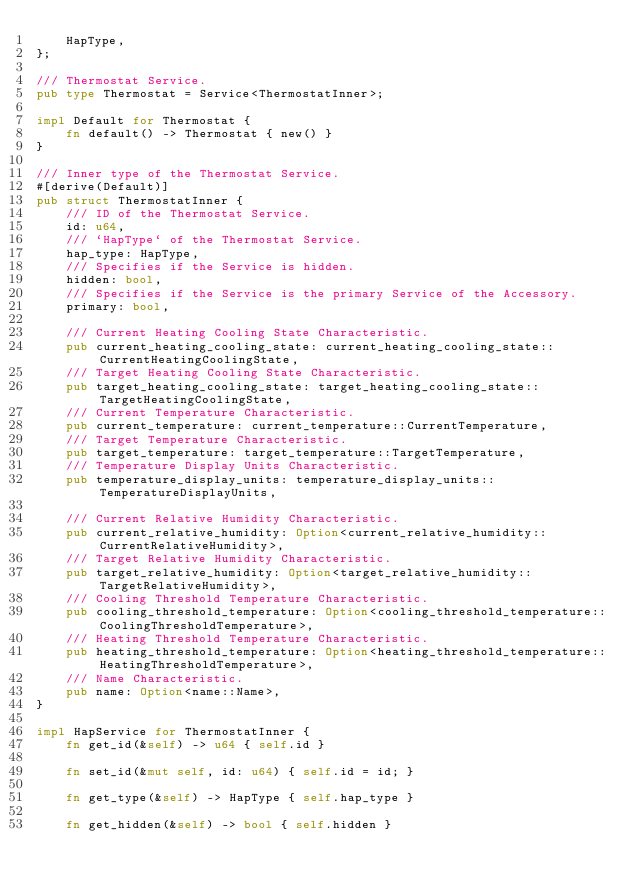Convert code to text. <code><loc_0><loc_0><loc_500><loc_500><_Rust_>    HapType,
};

/// Thermostat Service.
pub type Thermostat = Service<ThermostatInner>;

impl Default for Thermostat {
    fn default() -> Thermostat { new() }
}

/// Inner type of the Thermostat Service.
#[derive(Default)]
pub struct ThermostatInner {
    /// ID of the Thermostat Service.
    id: u64,
    /// `HapType` of the Thermostat Service.
    hap_type: HapType,
    /// Specifies if the Service is hidden.
    hidden: bool,
    /// Specifies if the Service is the primary Service of the Accessory.
    primary: bool,

    /// Current Heating Cooling State Characteristic.
    pub current_heating_cooling_state: current_heating_cooling_state::CurrentHeatingCoolingState,
    /// Target Heating Cooling State Characteristic.
    pub target_heating_cooling_state: target_heating_cooling_state::TargetHeatingCoolingState,
    /// Current Temperature Characteristic.
    pub current_temperature: current_temperature::CurrentTemperature,
    /// Target Temperature Characteristic.
    pub target_temperature: target_temperature::TargetTemperature,
    /// Temperature Display Units Characteristic.
    pub temperature_display_units: temperature_display_units::TemperatureDisplayUnits,

    /// Current Relative Humidity Characteristic.
    pub current_relative_humidity: Option<current_relative_humidity::CurrentRelativeHumidity>,
    /// Target Relative Humidity Characteristic.
    pub target_relative_humidity: Option<target_relative_humidity::TargetRelativeHumidity>,
    /// Cooling Threshold Temperature Characteristic.
    pub cooling_threshold_temperature: Option<cooling_threshold_temperature::CoolingThresholdTemperature>,
    /// Heating Threshold Temperature Characteristic.
    pub heating_threshold_temperature: Option<heating_threshold_temperature::HeatingThresholdTemperature>,
    /// Name Characteristic.
    pub name: Option<name::Name>,
}

impl HapService for ThermostatInner {
    fn get_id(&self) -> u64 { self.id }

    fn set_id(&mut self, id: u64) { self.id = id; }

    fn get_type(&self) -> HapType { self.hap_type }

    fn get_hidden(&self) -> bool { self.hidden }
</code> 